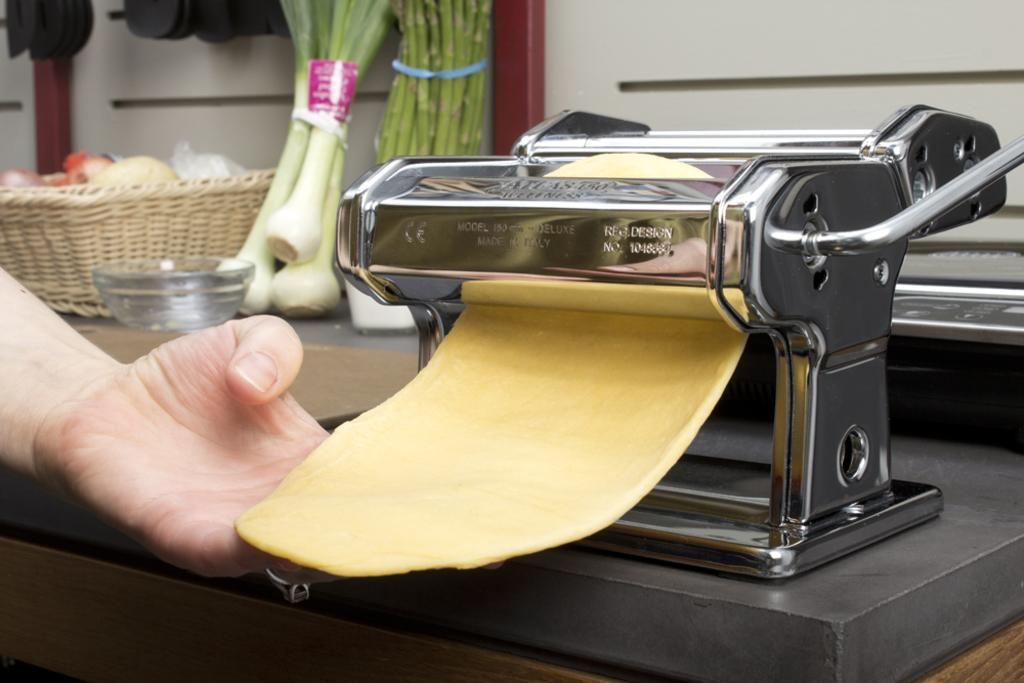<image>
Offer a succinct explanation of the picture presented. Someone makes pasta in a pasta maker that was made in Italy. 